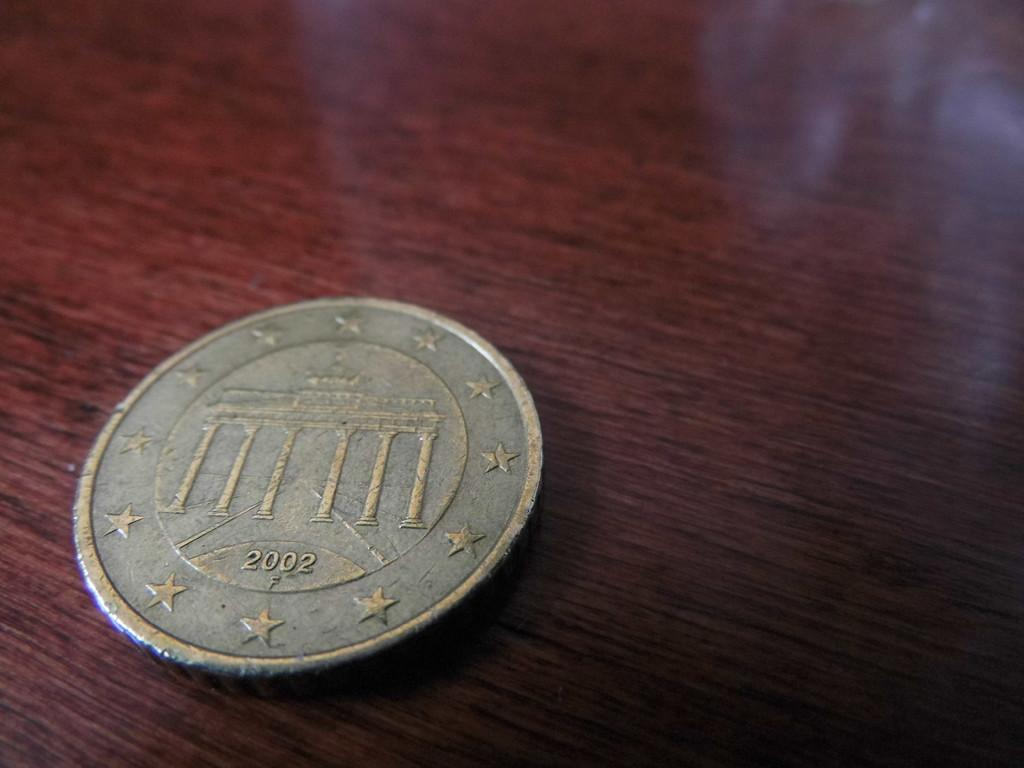What object is visible in the image? There is a coin in the image. Where is the coin located? The coin is placed on a table. Is there a cobweb visible on the coin in the image? No, there is no cobweb visible on the coin in the image. Can you tell me how much wealth the person in the image has based on the coin? The image does not provide enough information to determine the person's wealth based on the coin. 